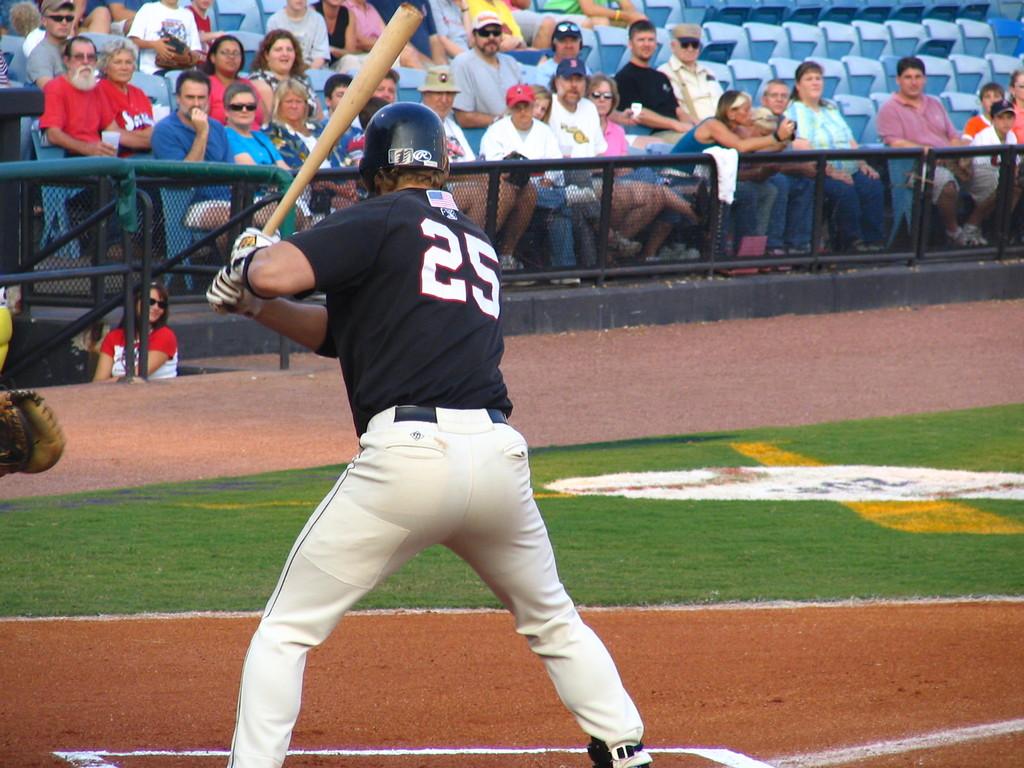What is the jersey number of the player shown?
Your answer should be very brief. 25. What is the at bat players number?
Ensure brevity in your answer.  25. 